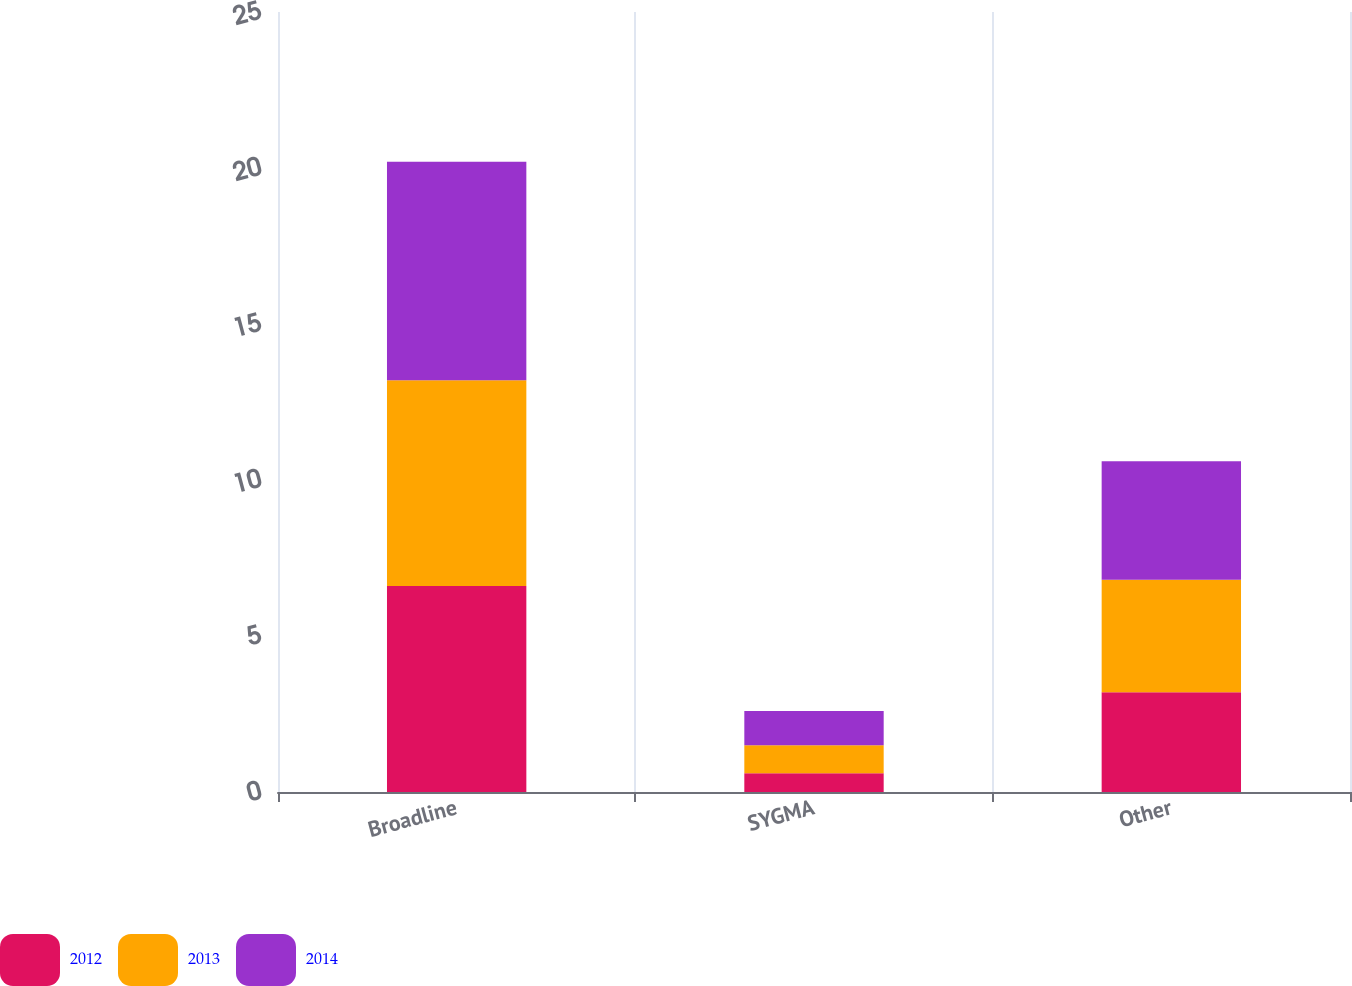Convert chart. <chart><loc_0><loc_0><loc_500><loc_500><stacked_bar_chart><ecel><fcel>Broadline<fcel>SYGMA<fcel>Other<nl><fcel>2012<fcel>6.6<fcel>0.6<fcel>3.2<nl><fcel>2013<fcel>6.6<fcel>0.9<fcel>3.6<nl><fcel>2014<fcel>7<fcel>1.1<fcel>3.8<nl></chart> 